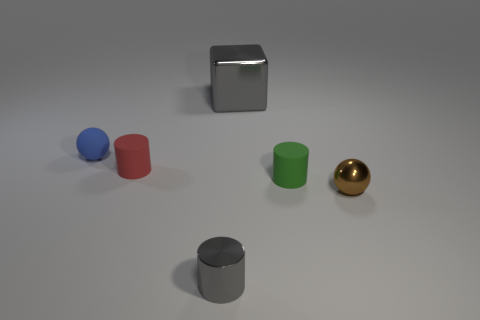Subtract all cyan cylinders. Subtract all gray cubes. How many cylinders are left? 3 Add 3 large green rubber blocks. How many objects exist? 9 Subtract all cubes. How many objects are left? 5 Subtract all green rubber things. Subtract all green rubber cylinders. How many objects are left? 4 Add 6 red things. How many red things are left? 7 Add 6 big blue cylinders. How many big blue cylinders exist? 6 Subtract 0 cyan cylinders. How many objects are left? 6 